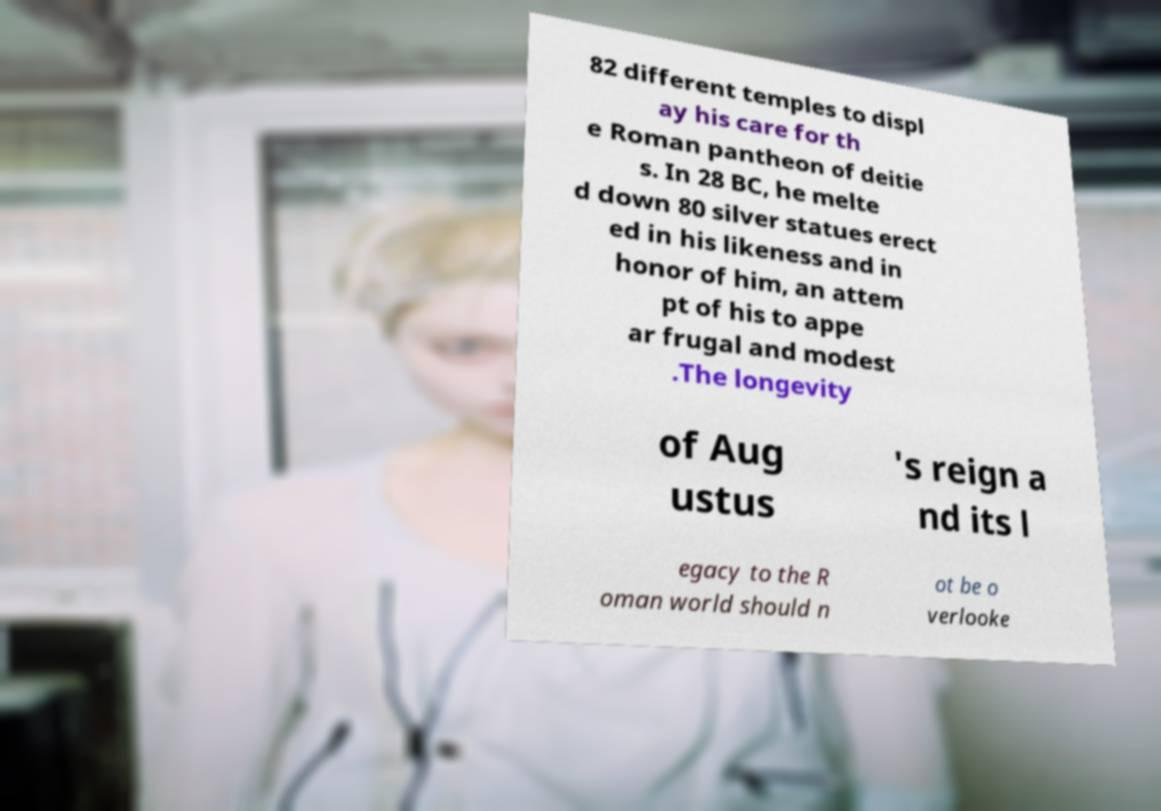Could you extract and type out the text from this image? 82 different temples to displ ay his care for th e Roman pantheon of deitie s. In 28 BC, he melte d down 80 silver statues erect ed in his likeness and in honor of him, an attem pt of his to appe ar frugal and modest .The longevity of Aug ustus 's reign a nd its l egacy to the R oman world should n ot be o verlooke 